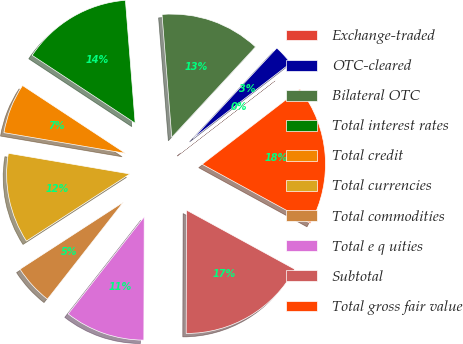Convert chart. <chart><loc_0><loc_0><loc_500><loc_500><pie_chart><fcel>Exchange-traded<fcel>OTC-cleared<fcel>Bilateral OTC<fcel>Total interest rates<fcel>Total credit<fcel>Total currencies<fcel>Total commodities<fcel>Total e q uities<fcel>Subtotal<fcel>Total gross fair value<nl><fcel>0.02%<fcel>2.65%<fcel>13.15%<fcel>14.47%<fcel>6.59%<fcel>11.84%<fcel>5.27%<fcel>10.53%<fcel>17.09%<fcel>18.4%<nl></chart> 